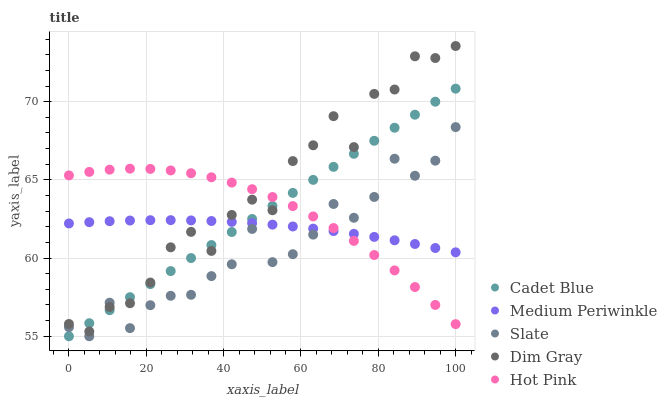Does Slate have the minimum area under the curve?
Answer yes or no. Yes. Does Dim Gray have the maximum area under the curve?
Answer yes or no. Yes. Does Cadet Blue have the minimum area under the curve?
Answer yes or no. No. Does Cadet Blue have the maximum area under the curve?
Answer yes or no. No. Is Cadet Blue the smoothest?
Answer yes or no. Yes. Is Dim Gray the roughest?
Answer yes or no. Yes. Is Medium Periwinkle the smoothest?
Answer yes or no. No. Is Medium Periwinkle the roughest?
Answer yes or no. No. Does Slate have the lowest value?
Answer yes or no. Yes. Does Medium Periwinkle have the lowest value?
Answer yes or no. No. Does Dim Gray have the highest value?
Answer yes or no. Yes. Does Cadet Blue have the highest value?
Answer yes or no. No. Does Medium Periwinkle intersect Dim Gray?
Answer yes or no. Yes. Is Medium Periwinkle less than Dim Gray?
Answer yes or no. No. Is Medium Periwinkle greater than Dim Gray?
Answer yes or no. No. 